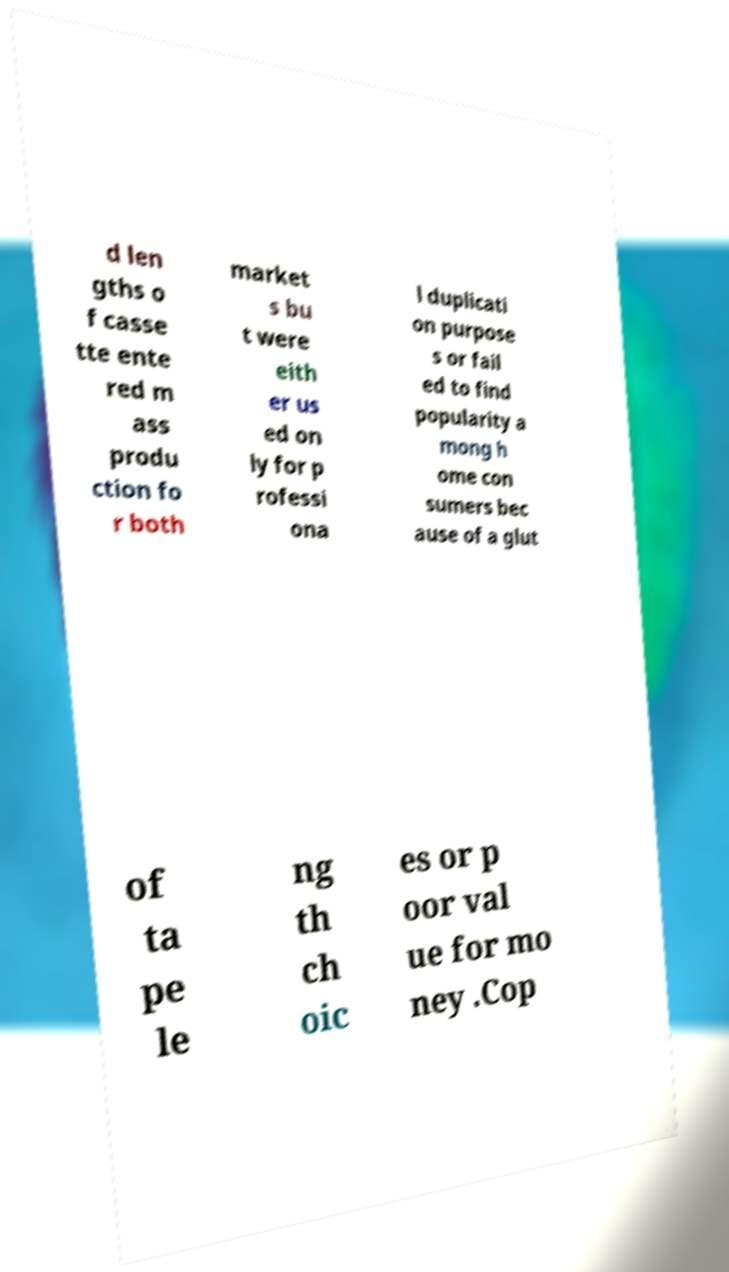For documentation purposes, I need the text within this image transcribed. Could you provide that? d len gths o f casse tte ente red m ass produ ction fo r both market s bu t were eith er us ed on ly for p rofessi ona l duplicati on purpose s or fail ed to find popularity a mong h ome con sumers bec ause of a glut of ta pe le ng th ch oic es or p oor val ue for mo ney .Cop 